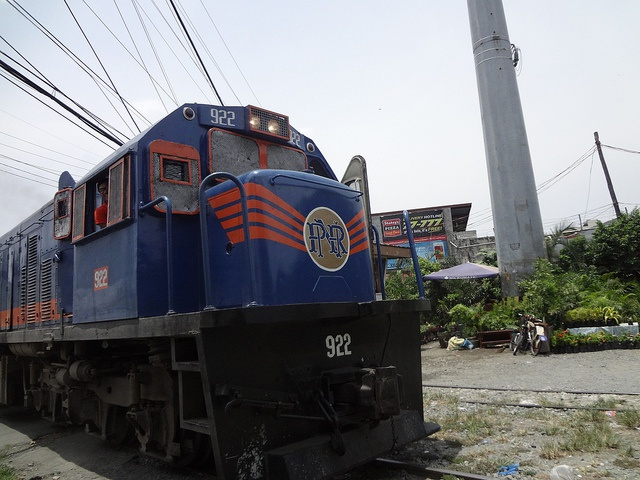Describe the objects in this image and their specific colors. I can see train in lightgray, black, gray, navy, and darkblue tones, people in lightgray, black, navy, and gray tones, bicycle in lightgray, black, gray, maroon, and darkgray tones, people in lightgray, black, maroon, brown, and gray tones, and bicycle in lightgray, black, gray, and darkgray tones in this image. 